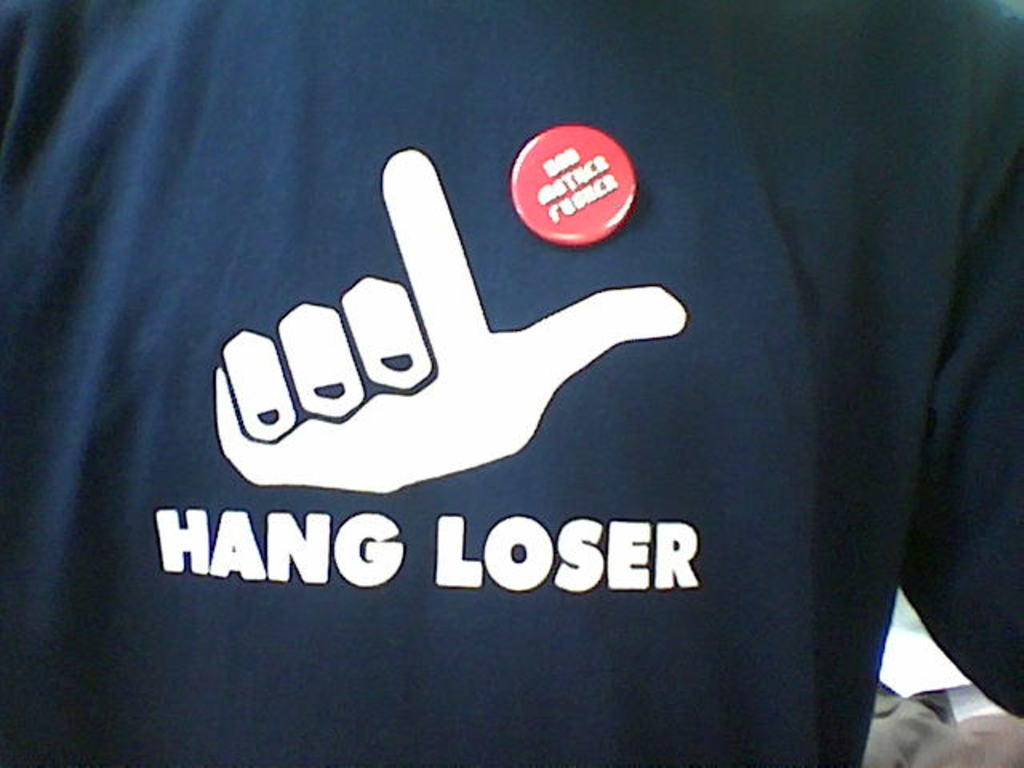What does the phrase 'HANG LOSER' on the t-shirt signify? The phrase 'HANG LOSER' on the t-shirt is a playful twist on the 'hang loose' gesture, which is often associated with surf culture and signifies a relaxed, carefree attitude. Here, the modification of 'loose' to 'loser' adds an element of self-deprecating humor, suggesting that the wearer doesn't take themselves too seriously and enjoys a good joke. 